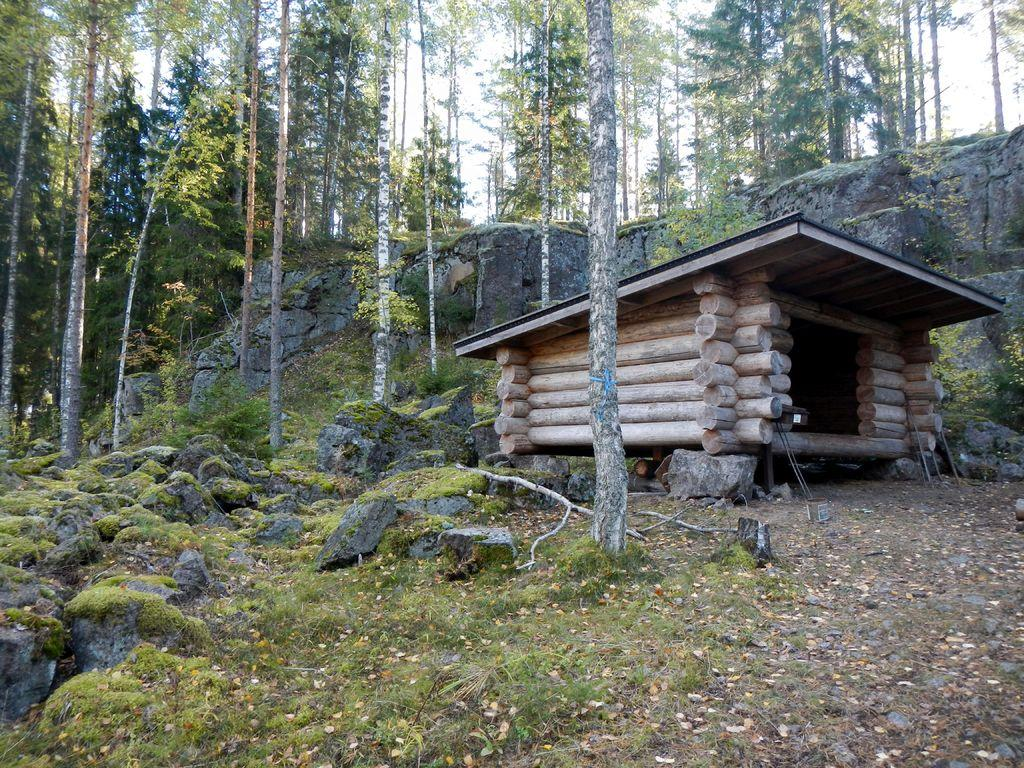What type of structure is present in the image? There is a shed in the image. What can be seen in the background of the image? There are trees and rocks in the background of the image. What is visible at the bottom of the image? The ground is visible at the bottom of the image. What type of silk is being used to cover the shed in the image? There is no silk present in the image, nor is the shed covered by any material. 